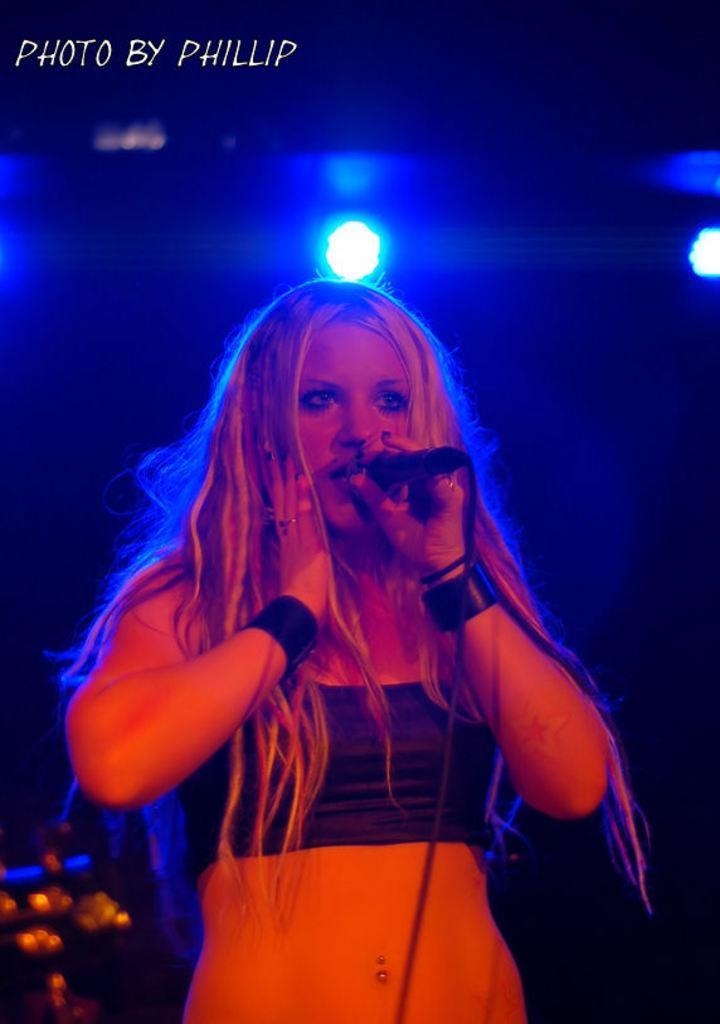In one or two sentences, can you explain what this image depicts? In this image we can see a lady is standing and holding a mike in her hand. On the top of the image we can see a text. 